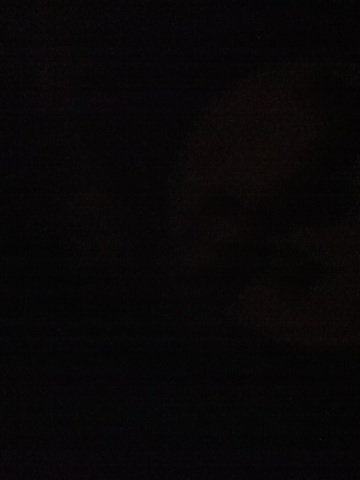Imagine the most mysterious and fantastical scene possible in this darkness. In the inky darkness, imagine an ancient, mythical city built entirely of black obsidian. The streets are paved with glowing runes that emit a dim, ethereal light. Shadows dance and whisper secrets of an age-old lore, and towering spires vanish into the night sky, wrapped in veils of mist. The faint flicker of a distant torchlight hints at the presence of elusive beings, guardians of ancient wisdom, who watch over the city from the shadows. 